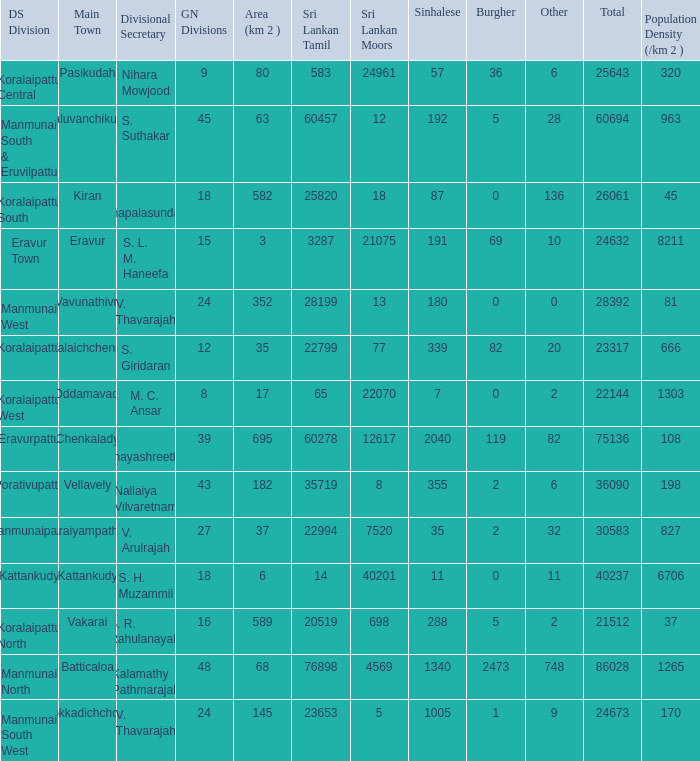Kaluvanchikudy is the main town in what DS division? Manmunai South & Eruvilpattu. 